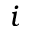<formula> <loc_0><loc_0><loc_500><loc_500>i</formula> 